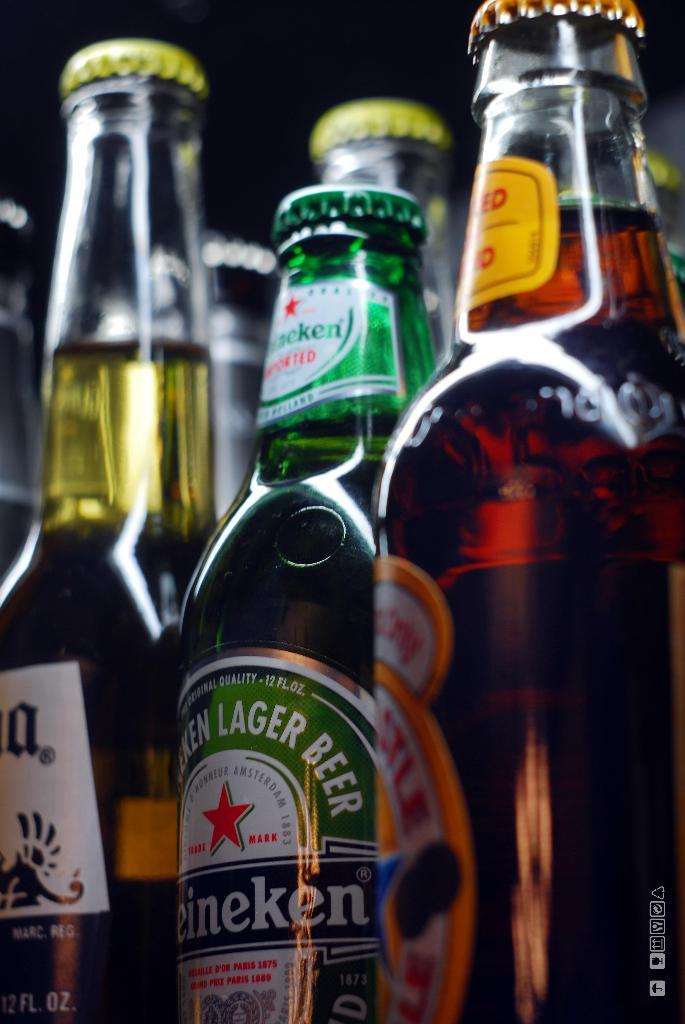<image>
Offer a succinct explanation of the picture presented. A bottle of Heineken beer is placed between other bottles of beer. 